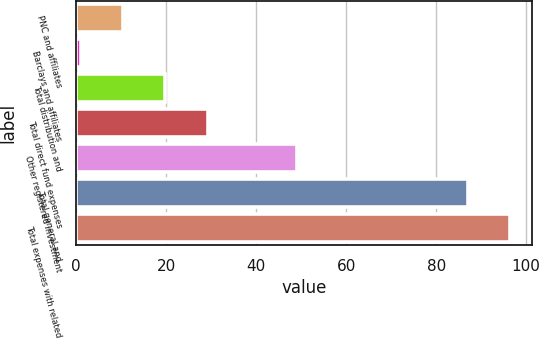<chart> <loc_0><loc_0><loc_500><loc_500><bar_chart><fcel>PNC and affiliates<fcel>Barclays and affiliates<fcel>Total distribution and<fcel>Total direct fund expenses<fcel>Other registered investment<fcel>Total general and<fcel>Total expenses with related<nl><fcel>10.4<fcel>1<fcel>19.8<fcel>29.2<fcel>49<fcel>87<fcel>96.4<nl></chart> 